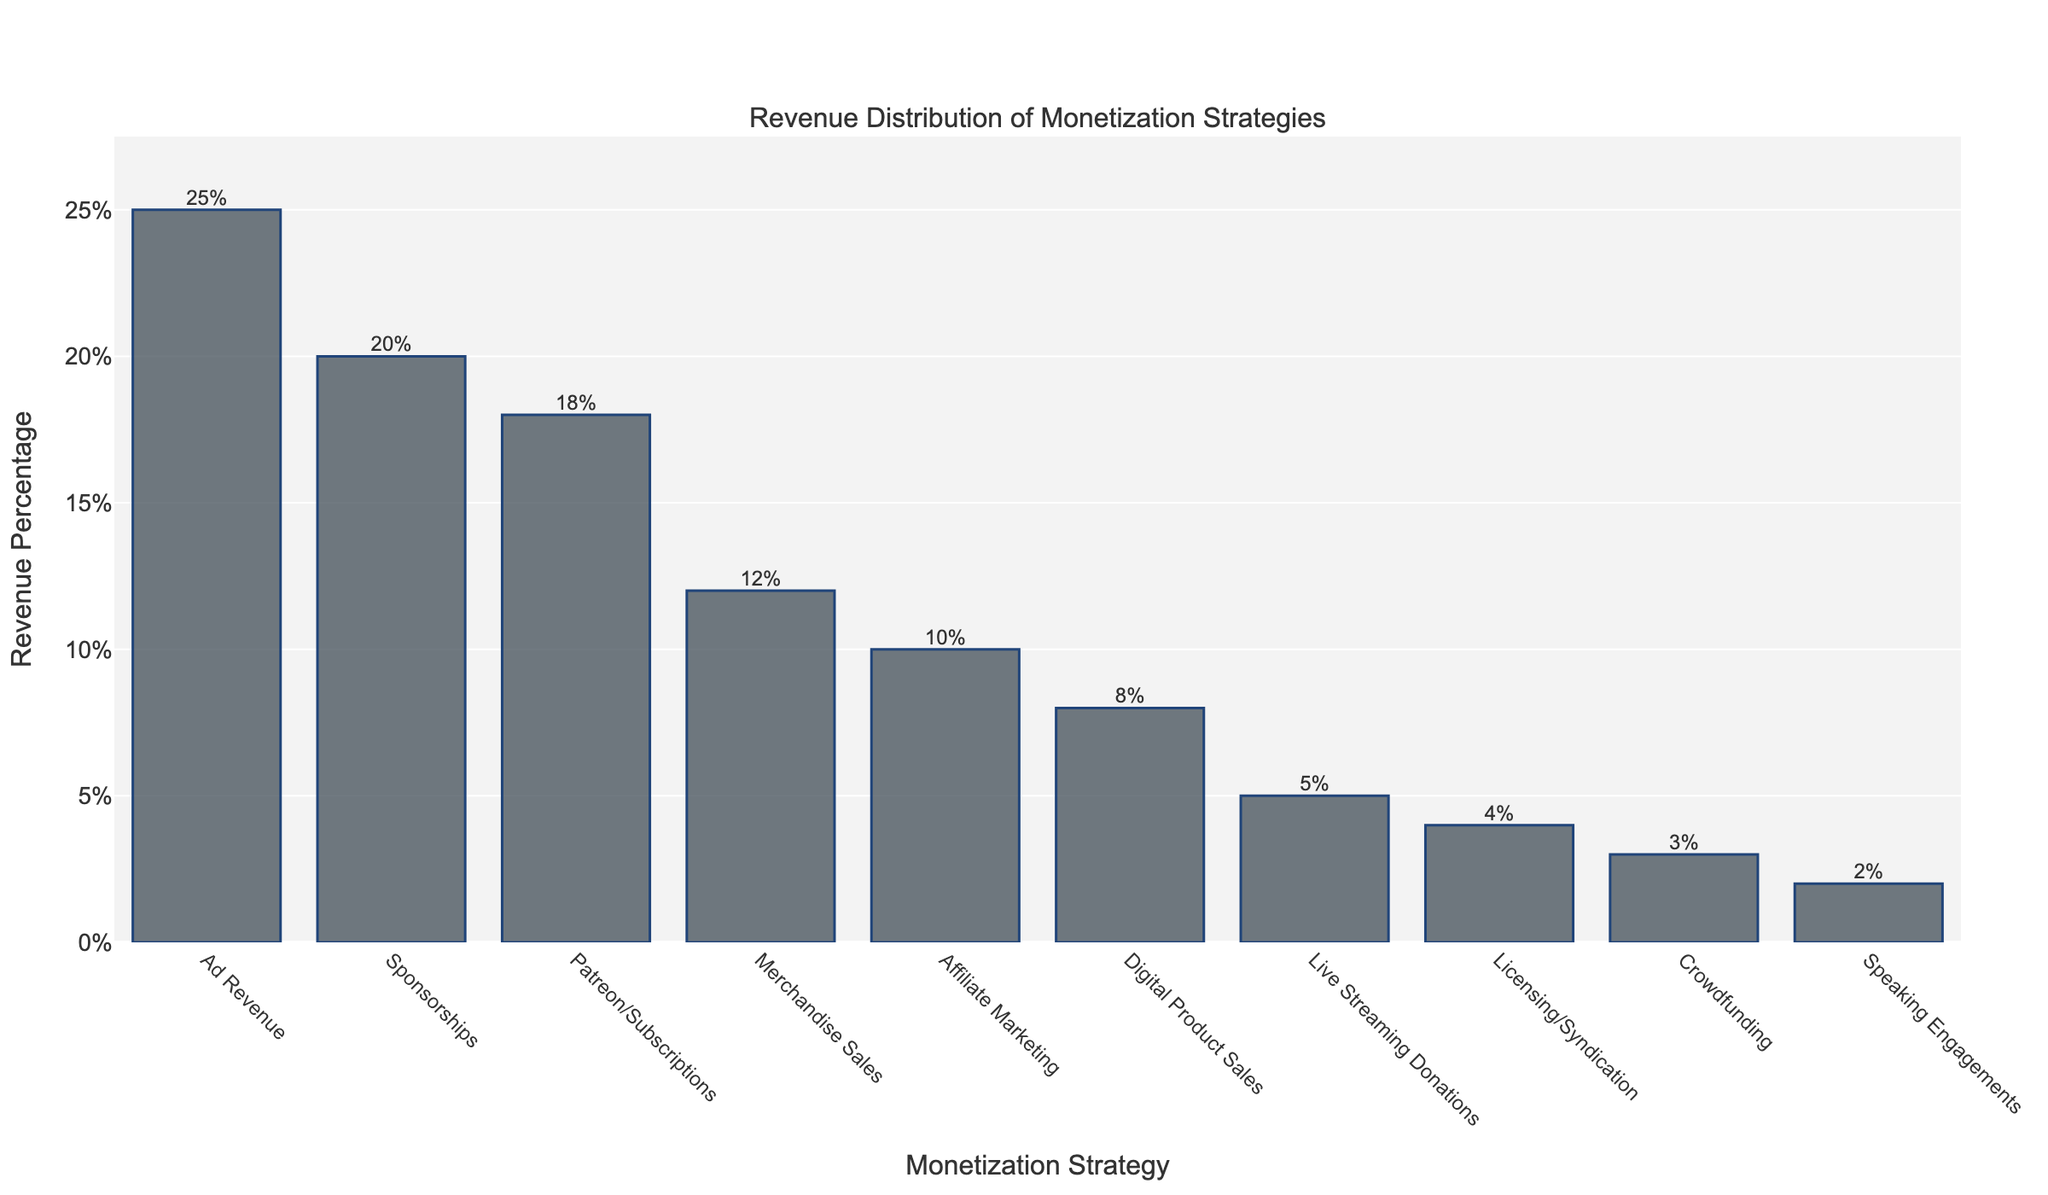What is the highest revenue percentage monetization strategy? The highest bar represents the highest revenue percentage. In the chart, the tallest bar corresponds to Ad Revenue, which is 25%.
Answer: 25% What is the total revenue percentage for all strategies that contribute less than 10% individually? Identify bars with revenue percentages less than 10% (Affiliate Marketing, Digital Product Sales, Live Streaming Donations, Licensing/Syndication, Crowdfunding, Speaking Engagements) and sum their values: 10% + 8% + 5% + 4% + 3% + 2% = 32%.
Answer: 32% How much more revenue percentage does Ad Revenue generate compared to Sponsorships? Find the difference in height between the bars for Ad Revenue and Sponsorships: 25% - 20% = 5%.
Answer: 5% Which monetization strategy ranks fourth in terms of revenue percentage? Identify the fourth tallest bar from the chart. The bars in descending order are Ad Revenue, Sponsorships, Patreon/Subscriptions, Merchandise Sales. So, Merchandise Sales is fourth at 12%.
Answer: Merchandise Sales What is the combined revenue percentage of the top three monetization strategies? Sum the percentages of the top three bars: Ad Revenue (25%), Sponsorships (20%), and Patreon/Subscriptions (18%): 25% + 20% + 18% = 63%.
Answer: 63% How do the contributions of Licensing/Syndication and Crowdfunding compare? Compare the heights of bars for Licensing/Syndication and Crowdfunding. Licensing/Syndication has 4% and Crowdfunding has 3%. Thus, Licensing/Syndication contributes 1% more than Crowdfunding.
Answer: 1% What is the average revenue percentage of Digital Product Sales, Live Streaming Donations, and Licensing/Syndication? Find the average of these percentages: (8% + 5% + 4%) / 3 = 17% / 3 ≈ 5.67%.
Answer: 5.67% Which is the least common monetization strategy according to revenue percentage, and what is its value? The shortest bar represents the least common strategy. In the chart, the shortest bar corresponds to Speaking Engagements, which is 2%.
Answer: Speaking Engagements, 2% On the y-axis, what is the range of values displayed? The y-axis starts at 0% and extends slightly above the highest value considering space for labels. The highest value is 25%; typically, it might cap around 27.5% (max value + 10%).
Answer: 0% to around 27.5% What is the difference in revenue percentages between Patreon/Subscriptions and Merchandise Sales? Identify the heights of bars for Patreon/Subscriptions and Merchandise Sales and find the difference: 18% - 12% = 6%.
Answer: 6% 